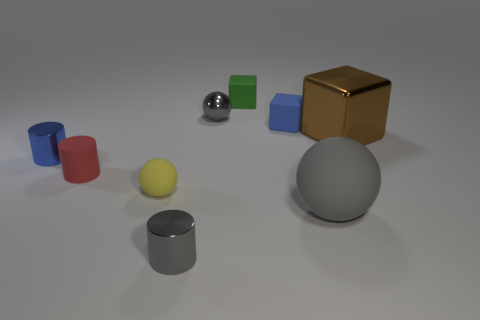There is a tiny thing that is the same color as the metal sphere; what material is it?
Make the answer very short. Metal. There is a tiny sphere that is behind the brown metallic object; does it have the same color as the big thing in front of the red thing?
Your answer should be very brief. Yes. There is a small ball that is to the right of the small yellow matte sphere; does it have the same color as the large matte object?
Provide a succinct answer. Yes. Are there an equal number of yellow objects that are left of the tiny matte sphere and gray rubber things?
Your response must be concise. No. Is there a shiny ball that has the same color as the large matte ball?
Give a very brief answer. Yes. Is the size of the gray metallic sphere the same as the shiny block?
Your answer should be very brief. No. There is a gray metallic thing on the right side of the metallic cylinder that is in front of the tiny blue metal cylinder; what is its size?
Provide a short and direct response. Small. There is a gray thing that is on the right side of the tiny gray metal cylinder and in front of the large brown metal thing; what is its size?
Your answer should be compact. Large. What number of blue matte blocks are the same size as the blue shiny thing?
Keep it short and to the point. 1. What number of metal objects are either purple objects or big brown things?
Your answer should be very brief. 1. 